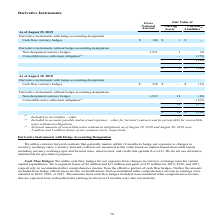According to Micron Technology's financial document, How does the company measure currency forward contracts? at fair value based on market-based observable inputs including currency exchange spot and forward rates, interest rates, and credit-risk spreads (Level 2). The document states: "nge rates. Currency forward contracts are measured at fair value based on market-based observable inputs including currency exchange spot and forward ..." Also, How does the company utilize its cash flow hedges? for our exposure from changes in currency exchange rates for certain capital expenditures. The document states: "Cash Flow Hedges : We utilize cash flow hedges for our exposure from changes in currency exchange rates for certain capital expenditures. We recognize..." Also, What was the cash flow currency hedges as of August 29, 2019? According to the financial document, $146. The relevant text states: "Cash flow currency hedges $ 146 $ 1 $ —..." Also, can you calculate: What is the change of the gross national amount of cash flow currency hedges from 2018 to 2019? Based on the calculation: 146 - 538 , the result is -392. This is based on the information: "Cash flow currency hedges $ 538 $ — $ (13) Cash flow currency hedges $ 146 $ 1 $ —..." The key data points involved are: 146, 538. Also, can you calculate: What is the average gross national amount of non-designated currency hedges from 2018 to 2019? To answer this question, I need to perform calculations using the financial data. The calculation is: (1,871+1,919)/2 , which equals 1895. This is based on the information: "Non-designated currency hedges 1,871 1 (9) Non-designated currency hedges 1,919 14 (10)..." The key data points involved are: 1,871, 1,919. Also, can you calculate: What is the ratio of the fair value of the total current assets in 2019 to that of 2018? Based on the calculation: 2/14 , the result is 0.14. This is based on the information: "Non-designated currency hedges 1,919 14 (10) Liabilities (2)..." The key data points involved are: 2. 